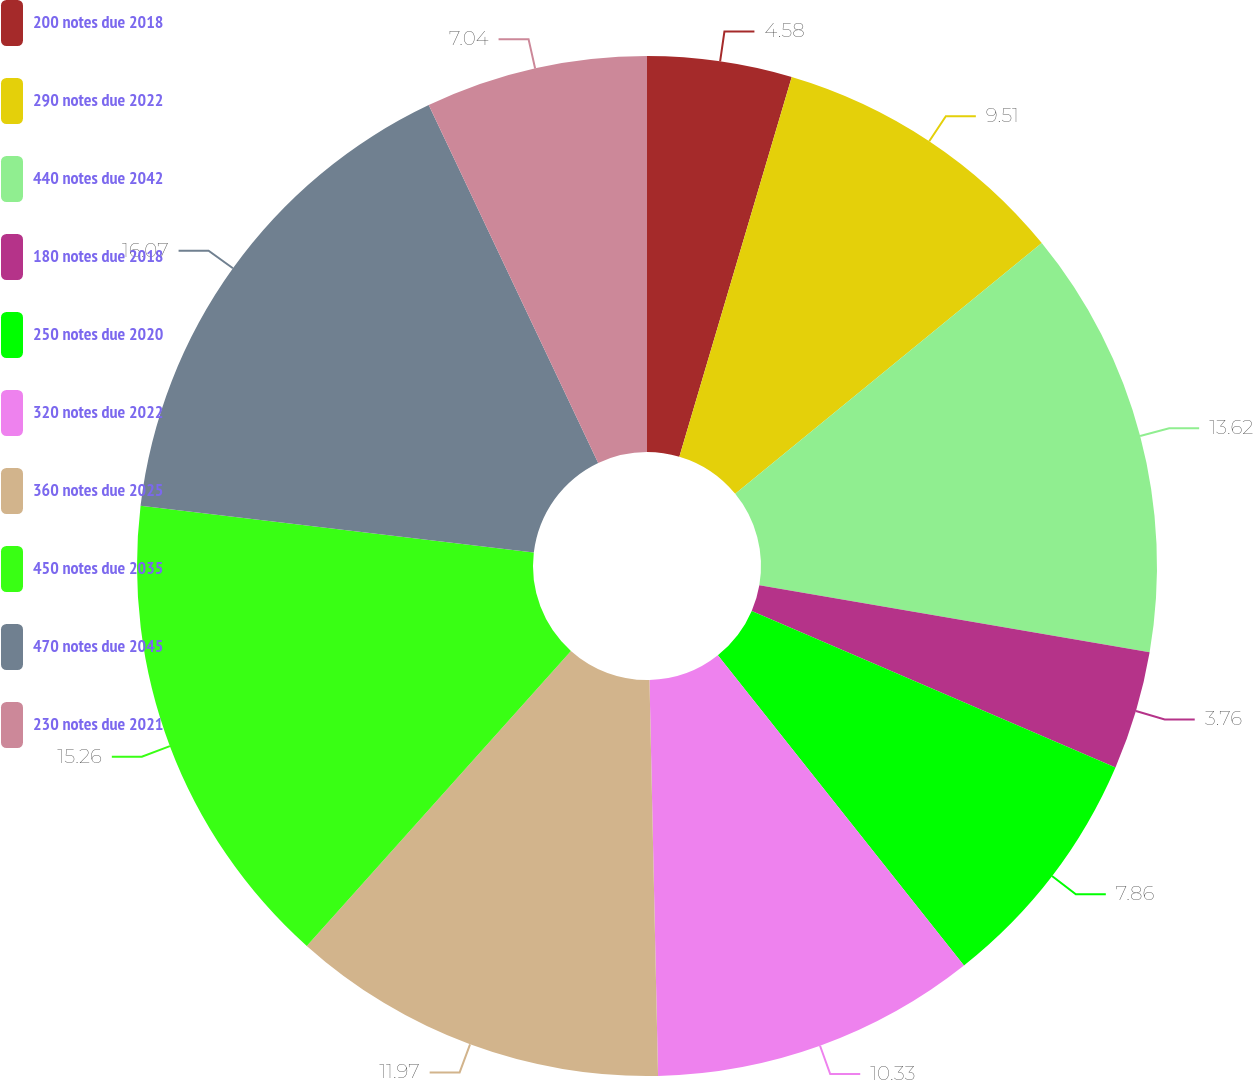Convert chart to OTSL. <chart><loc_0><loc_0><loc_500><loc_500><pie_chart><fcel>200 notes due 2018<fcel>290 notes due 2022<fcel>440 notes due 2042<fcel>180 notes due 2018<fcel>250 notes due 2020<fcel>320 notes due 2022<fcel>360 notes due 2025<fcel>450 notes due 2035<fcel>470 notes due 2045<fcel>230 notes due 2021<nl><fcel>4.58%<fcel>9.51%<fcel>13.62%<fcel>3.76%<fcel>7.86%<fcel>10.33%<fcel>11.97%<fcel>15.26%<fcel>16.08%<fcel>7.04%<nl></chart> 